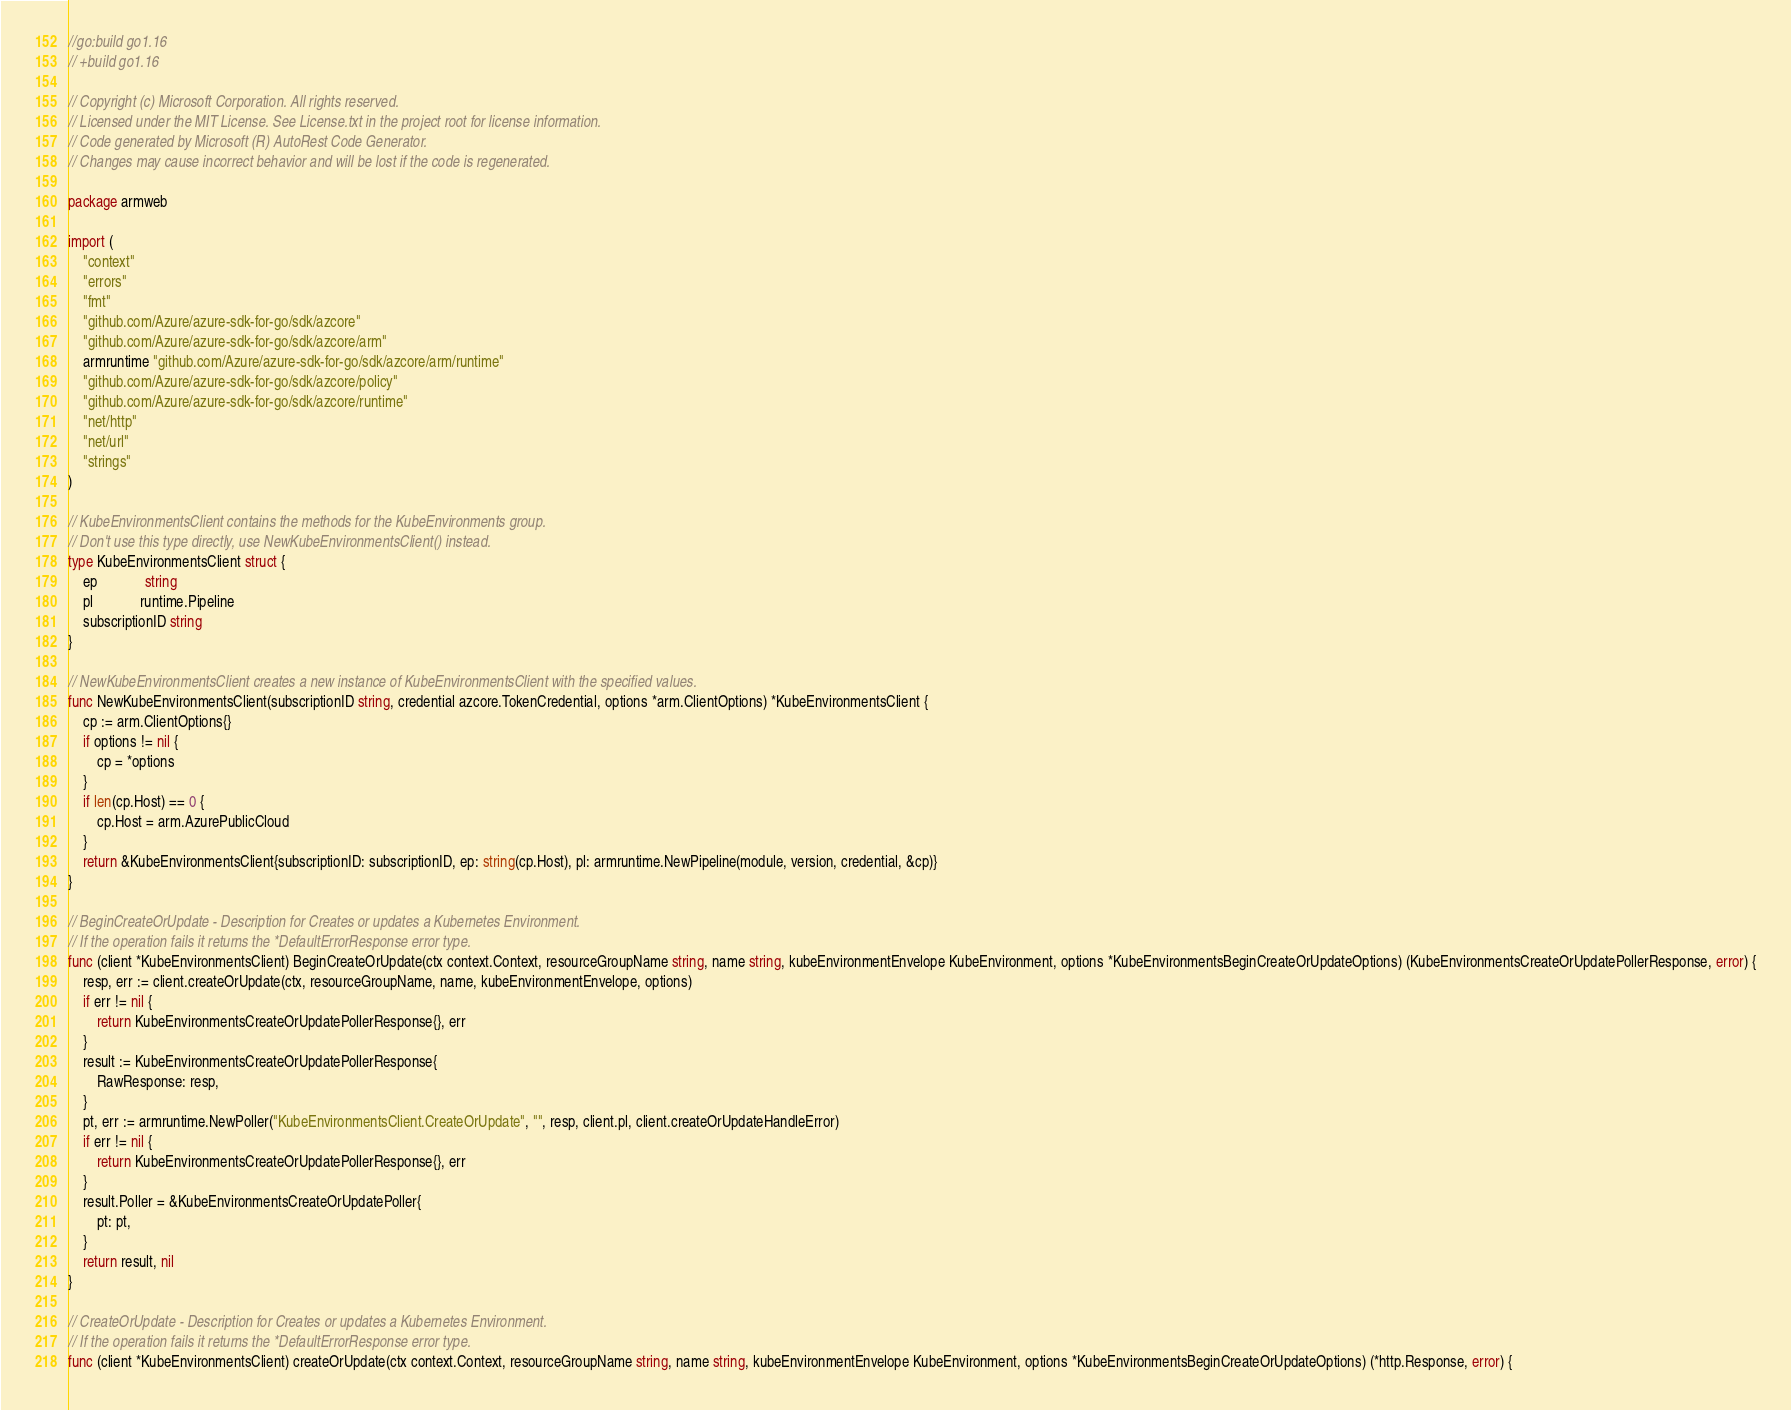Convert code to text. <code><loc_0><loc_0><loc_500><loc_500><_Go_>//go:build go1.16
// +build go1.16

// Copyright (c) Microsoft Corporation. All rights reserved.
// Licensed under the MIT License. See License.txt in the project root for license information.
// Code generated by Microsoft (R) AutoRest Code Generator.
// Changes may cause incorrect behavior and will be lost if the code is regenerated.

package armweb

import (
	"context"
	"errors"
	"fmt"
	"github.com/Azure/azure-sdk-for-go/sdk/azcore"
	"github.com/Azure/azure-sdk-for-go/sdk/azcore/arm"
	armruntime "github.com/Azure/azure-sdk-for-go/sdk/azcore/arm/runtime"
	"github.com/Azure/azure-sdk-for-go/sdk/azcore/policy"
	"github.com/Azure/azure-sdk-for-go/sdk/azcore/runtime"
	"net/http"
	"net/url"
	"strings"
)

// KubeEnvironmentsClient contains the methods for the KubeEnvironments group.
// Don't use this type directly, use NewKubeEnvironmentsClient() instead.
type KubeEnvironmentsClient struct {
	ep             string
	pl             runtime.Pipeline
	subscriptionID string
}

// NewKubeEnvironmentsClient creates a new instance of KubeEnvironmentsClient with the specified values.
func NewKubeEnvironmentsClient(subscriptionID string, credential azcore.TokenCredential, options *arm.ClientOptions) *KubeEnvironmentsClient {
	cp := arm.ClientOptions{}
	if options != nil {
		cp = *options
	}
	if len(cp.Host) == 0 {
		cp.Host = arm.AzurePublicCloud
	}
	return &KubeEnvironmentsClient{subscriptionID: subscriptionID, ep: string(cp.Host), pl: armruntime.NewPipeline(module, version, credential, &cp)}
}

// BeginCreateOrUpdate - Description for Creates or updates a Kubernetes Environment.
// If the operation fails it returns the *DefaultErrorResponse error type.
func (client *KubeEnvironmentsClient) BeginCreateOrUpdate(ctx context.Context, resourceGroupName string, name string, kubeEnvironmentEnvelope KubeEnvironment, options *KubeEnvironmentsBeginCreateOrUpdateOptions) (KubeEnvironmentsCreateOrUpdatePollerResponse, error) {
	resp, err := client.createOrUpdate(ctx, resourceGroupName, name, kubeEnvironmentEnvelope, options)
	if err != nil {
		return KubeEnvironmentsCreateOrUpdatePollerResponse{}, err
	}
	result := KubeEnvironmentsCreateOrUpdatePollerResponse{
		RawResponse: resp,
	}
	pt, err := armruntime.NewPoller("KubeEnvironmentsClient.CreateOrUpdate", "", resp, client.pl, client.createOrUpdateHandleError)
	if err != nil {
		return KubeEnvironmentsCreateOrUpdatePollerResponse{}, err
	}
	result.Poller = &KubeEnvironmentsCreateOrUpdatePoller{
		pt: pt,
	}
	return result, nil
}

// CreateOrUpdate - Description for Creates or updates a Kubernetes Environment.
// If the operation fails it returns the *DefaultErrorResponse error type.
func (client *KubeEnvironmentsClient) createOrUpdate(ctx context.Context, resourceGroupName string, name string, kubeEnvironmentEnvelope KubeEnvironment, options *KubeEnvironmentsBeginCreateOrUpdateOptions) (*http.Response, error) {</code> 